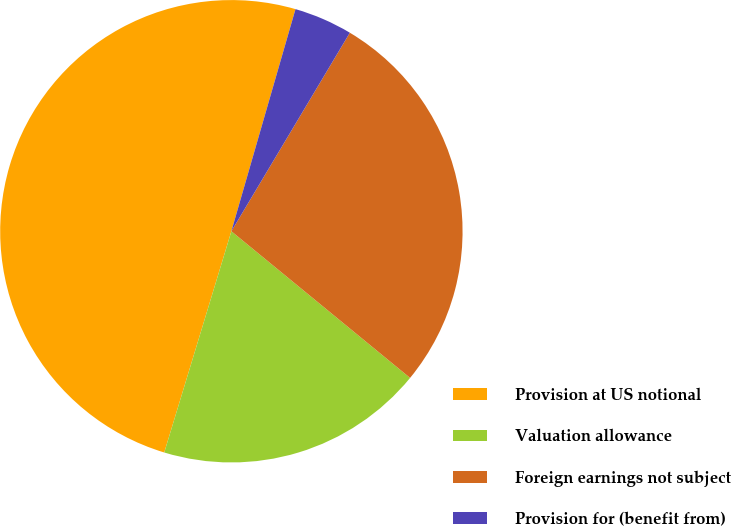Convert chart to OTSL. <chart><loc_0><loc_0><loc_500><loc_500><pie_chart><fcel>Provision at US notional<fcel>Valuation allowance<fcel>Foreign earnings not subject<fcel>Provision for (benefit from)<nl><fcel>49.78%<fcel>18.75%<fcel>27.37%<fcel>4.09%<nl></chart> 